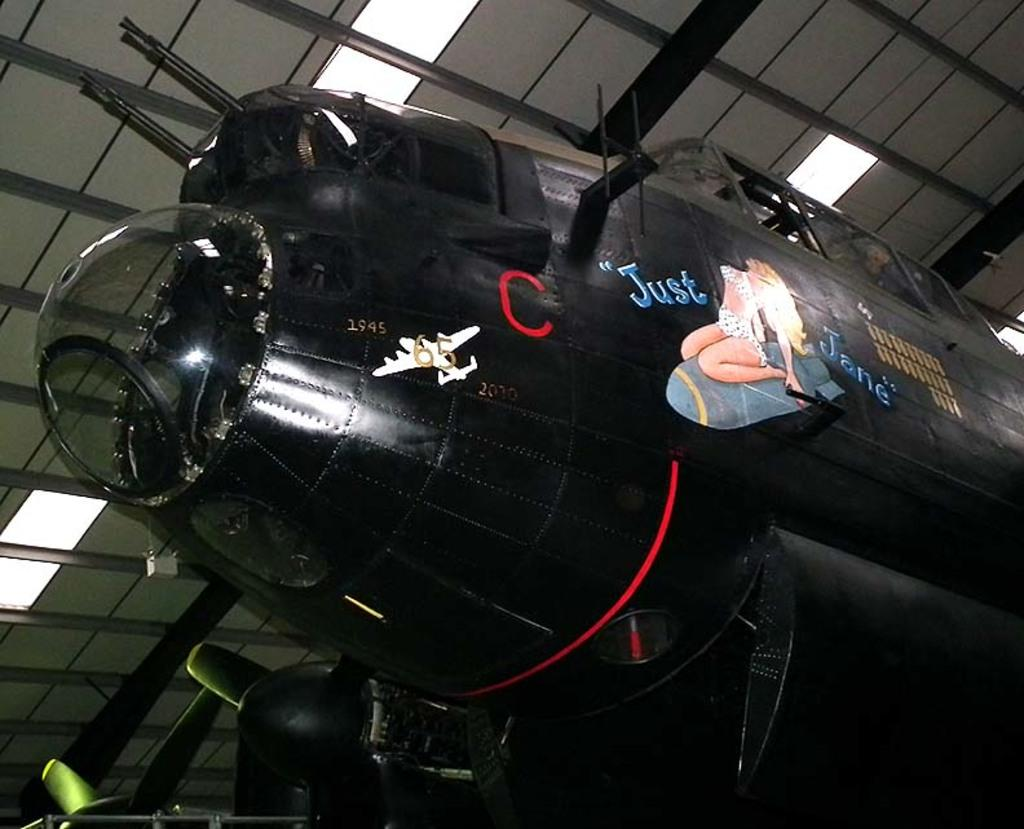What is the main subject of the picture? The main subject of the picture is an aircraft. What can be seen in the background of the picture? There is a roof and lights visible in the background of the picture. What type of sail can be seen on the aircraft in the image? There is no sail present on the aircraft in the image. How much payment is required to use the trail in the image? There is no trail present in the image, so it is not possible to determine any payment requirements. 